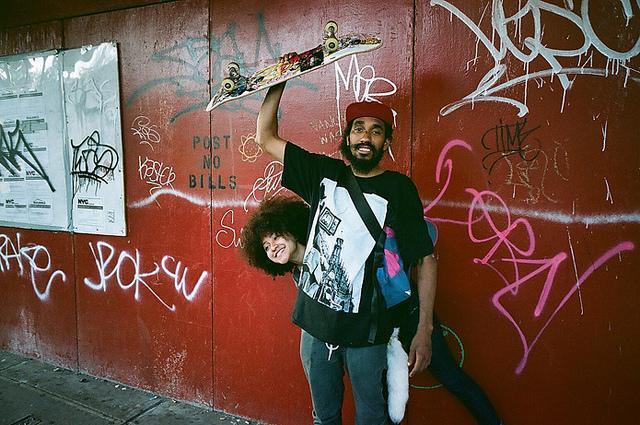How many people are in the photo?
Give a very brief answer. 2. How many handbags are there?
Give a very brief answer. 1. How many poles is the horse jumping?
Give a very brief answer. 0. 